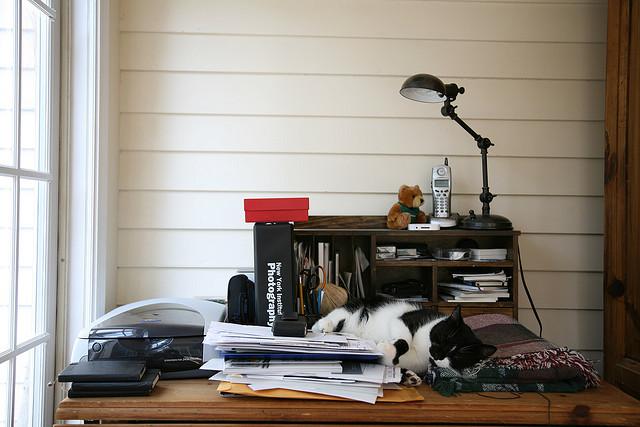Is the lamp battery powered or electric?
Answer briefly. Electric. Is  the cat sleeping?
Write a very short answer. Yes. What color is the cat?
Short answer required. Black and white. 